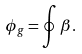<formula> <loc_0><loc_0><loc_500><loc_500>\phi _ { g } = \oint \beta .</formula> 